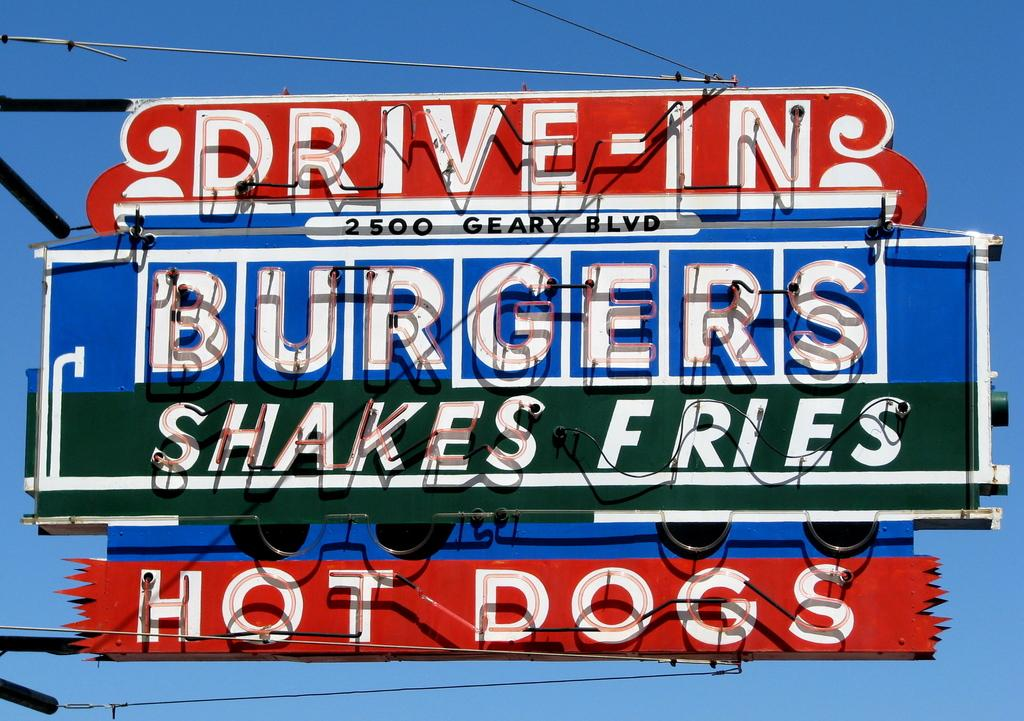<image>
Relay a brief, clear account of the picture shown. a sign saying drive in at 2500 geary blvd 